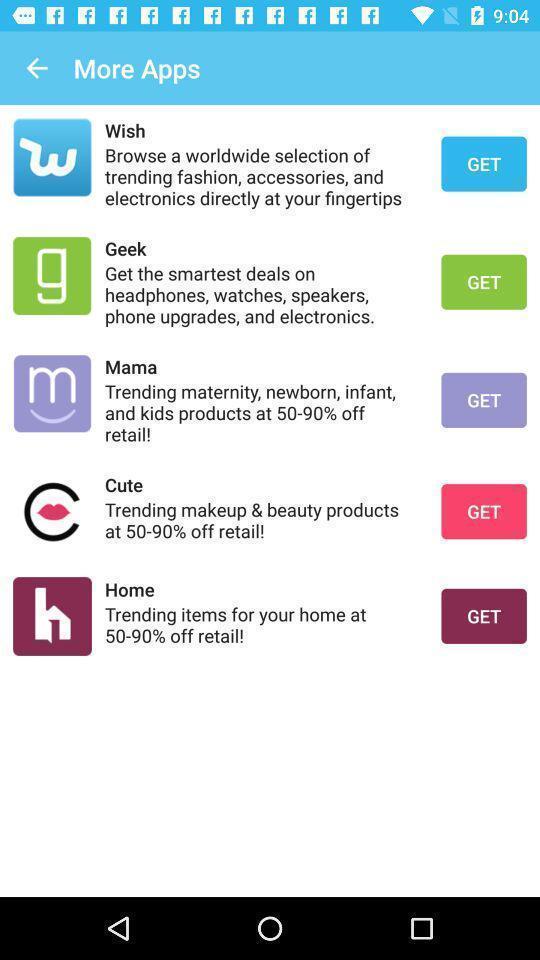Explain the elements present in this screenshot. Screen displaying the list of apps. 